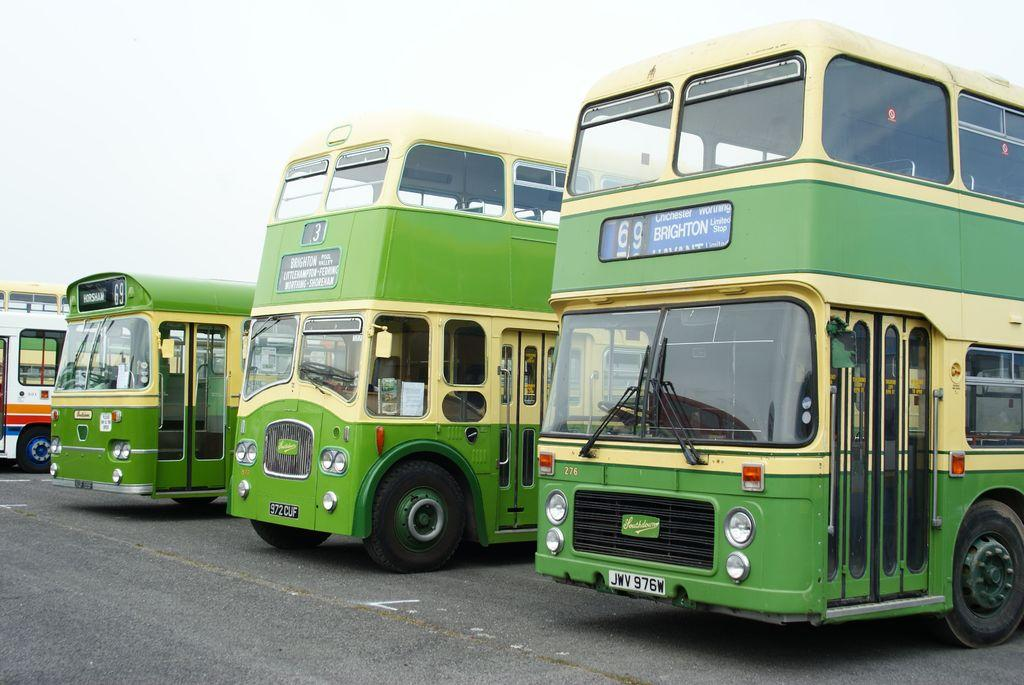<image>
Create a compact narrative representing the image presented. Three park green buses with a 976w written on license plate. 